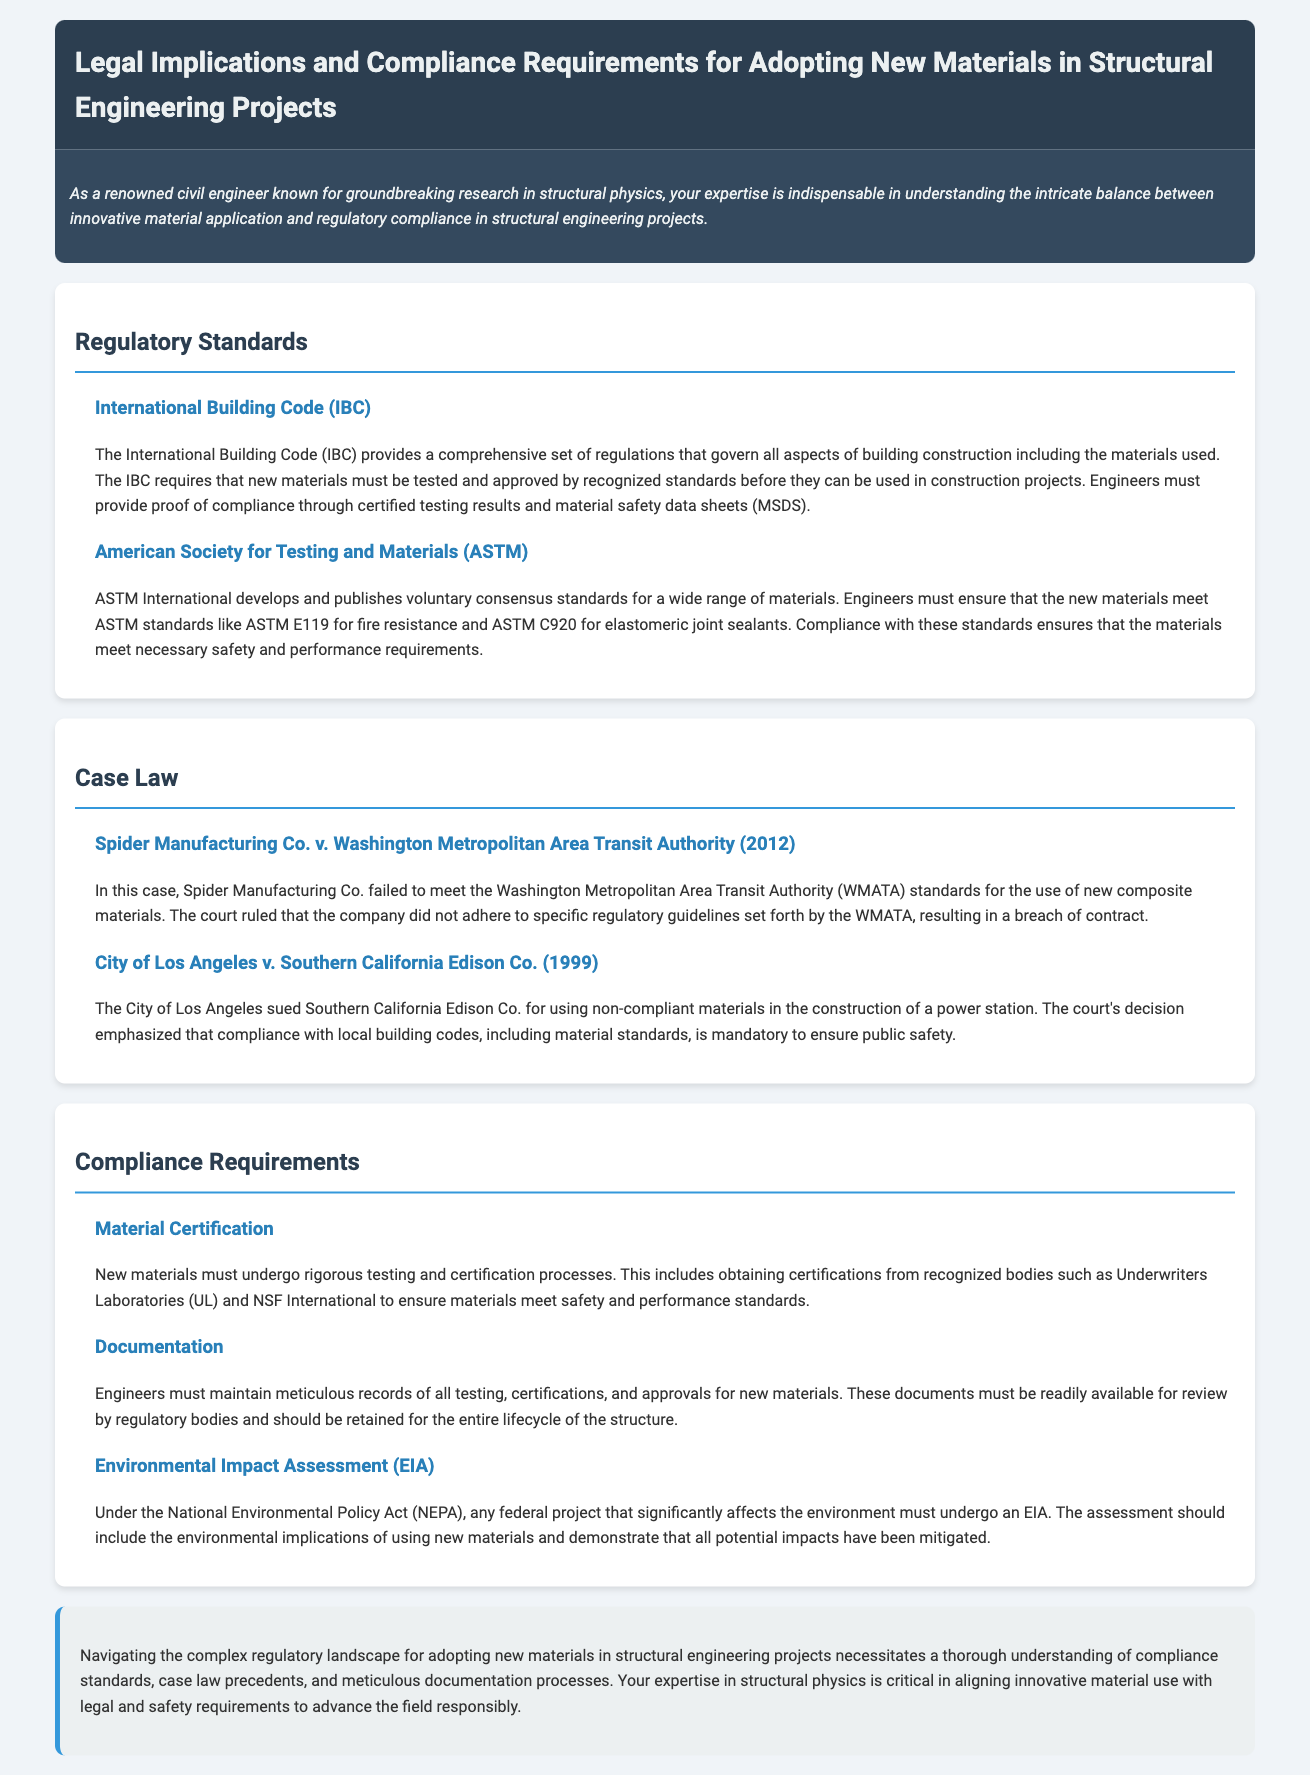What does the IBC require for new materials? The IBC requires that new materials must be tested and approved by recognized standards before they can be used in construction projects.
Answer: tested and approved Which organization publishes voluntary consensus standards? ASTM International develops and publishes voluntary consensus standards for a wide range of materials.
Answer: ASTM International What case involved Spider Manufacturing Co.? Spider Manufacturing Co. v. Washington Metropolitan Area Transit Authority is the case involving Spider Manufacturing Co.
Answer: Spider Manufacturing Co. v. Washington Metropolitan Area Transit Authority What is one requirement for new materials under NEPA? The National Environmental Policy Act requires that any federal project that significantly affects the environment must undergo an Environmental Impact Assessment (EIA).
Answer: Environmental Impact Assessment (EIA) Who must maintain records of testing and certification? Engineers must maintain meticulous records of all testing, certifications, and approvals for new materials.
Answer: Engineers 